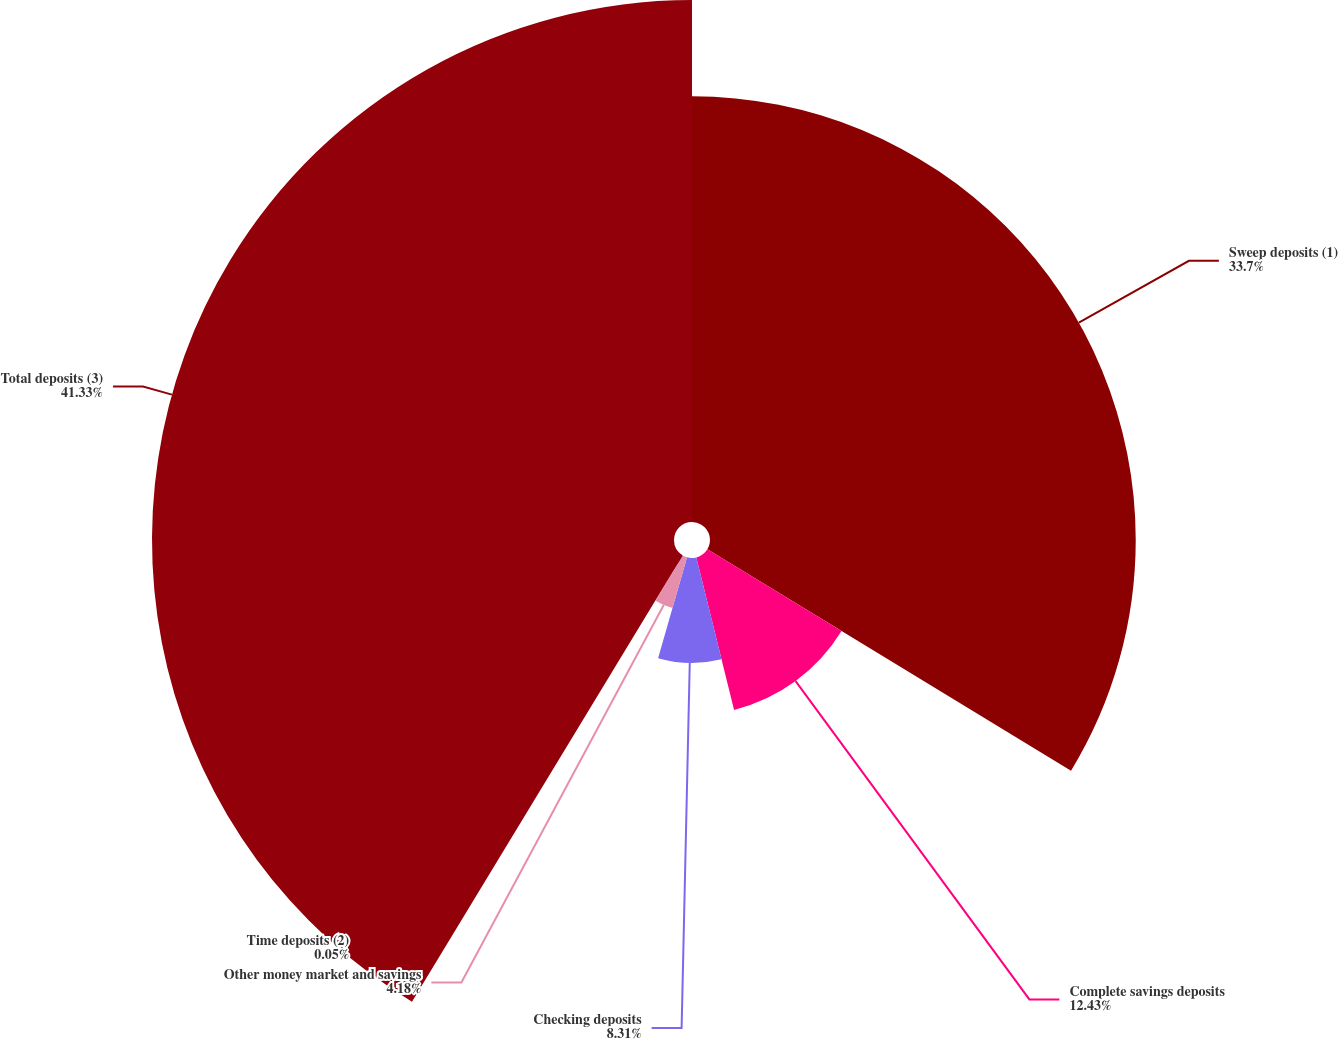<chart> <loc_0><loc_0><loc_500><loc_500><pie_chart><fcel>Sweep deposits (1)<fcel>Complete savings deposits<fcel>Checking deposits<fcel>Other money market and savings<fcel>Time deposits (2)<fcel>Total deposits (3)<nl><fcel>33.7%<fcel>12.43%<fcel>8.31%<fcel>4.18%<fcel>0.05%<fcel>41.32%<nl></chart> 